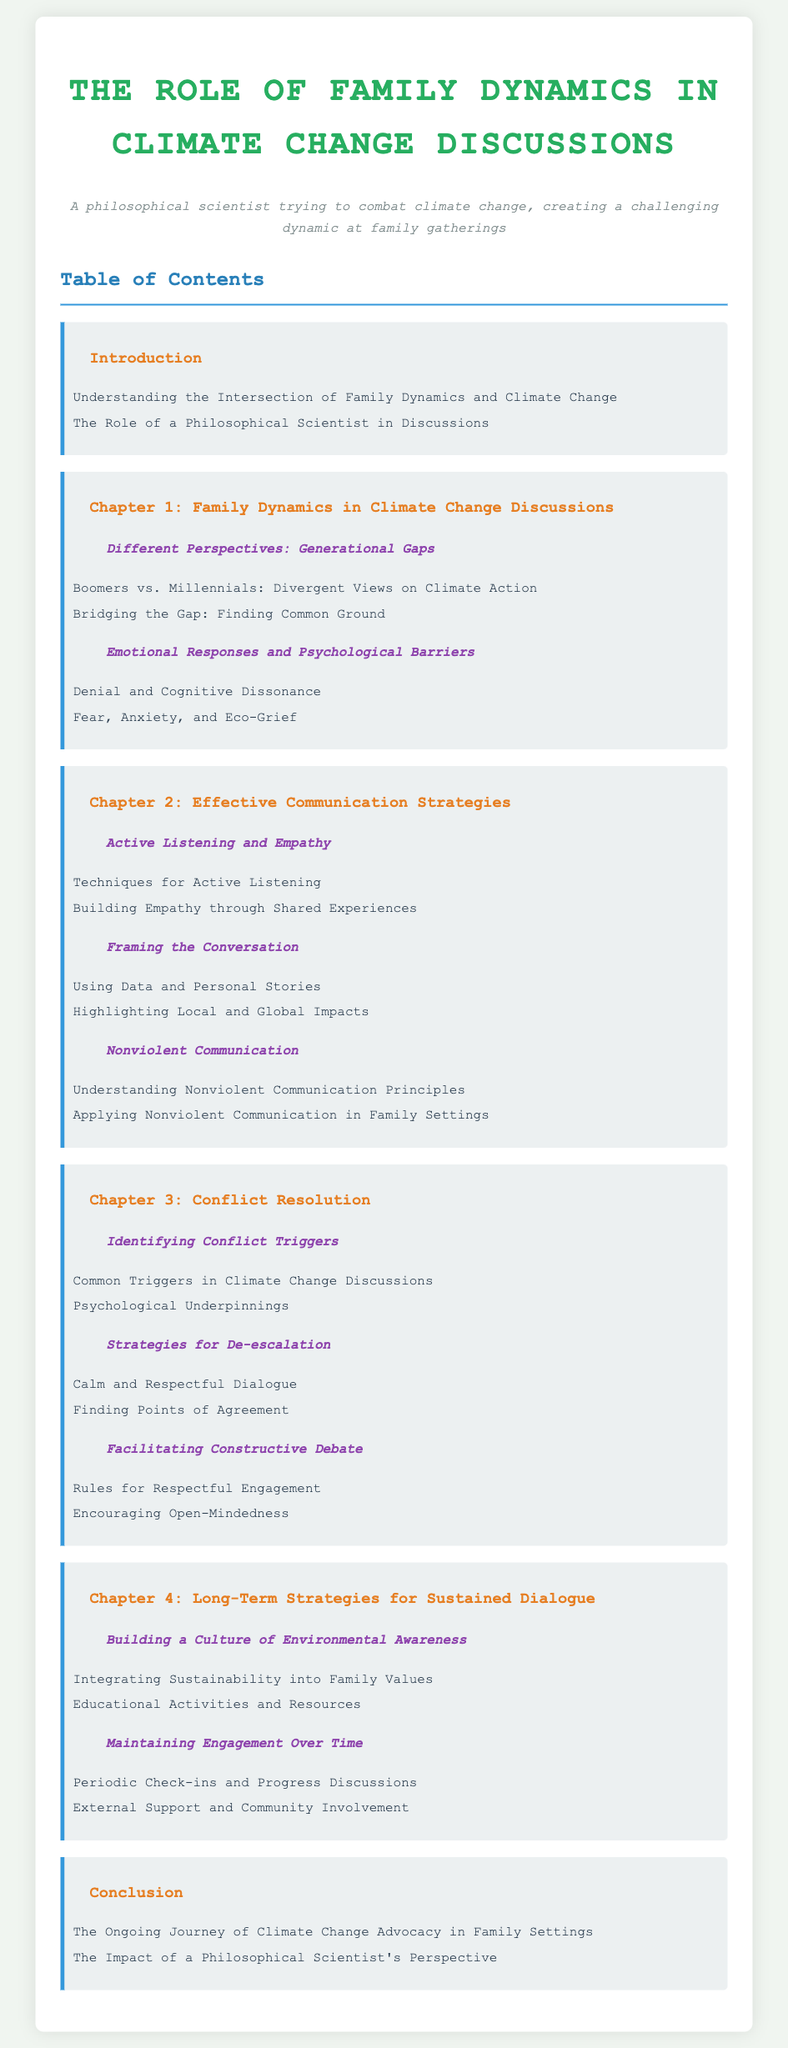What is the title of the document? The title of the document is presented at the top of the rendered document.
Answer: The Role of Family Dynamics in Climate Change Discussions How many chapters are in the document? The document includes several main chapters listed in the Table of Contents.
Answer: Four What is one emotional response discussed in the chapter on Family Dynamics? The chapter on Emotional Responses and Psychological Barriers lists specific emotional responses.
Answer: Eco-Grief What communication strategy is emphasized in Chapter 2? Chapter 2 focuses on various effective communication strategies for discussions.
Answer: Active Listening and Empathy What is a key theme of Chapter 4? The title of Chapter 4 suggests its focus on long-term approaches.
Answer: Long-Term Strategies for Sustained Dialogue What type of dialogue is encouraged in the Conflict Resolution chapter? The chapter title indicates a focus on respectful dialogue during discussions.
Answer: Calm and Respectful Dialogue What aspect of family values is highlighted in the Long-Term Strategies chapter? The Long-Term Strategies chapter discusses integrating certain principles into family values.
Answer: Environmental Awareness What is identified as a psychological barrier in discussions? The section lists specific barriers impacting discussions about climate change.
Answer: Denial 